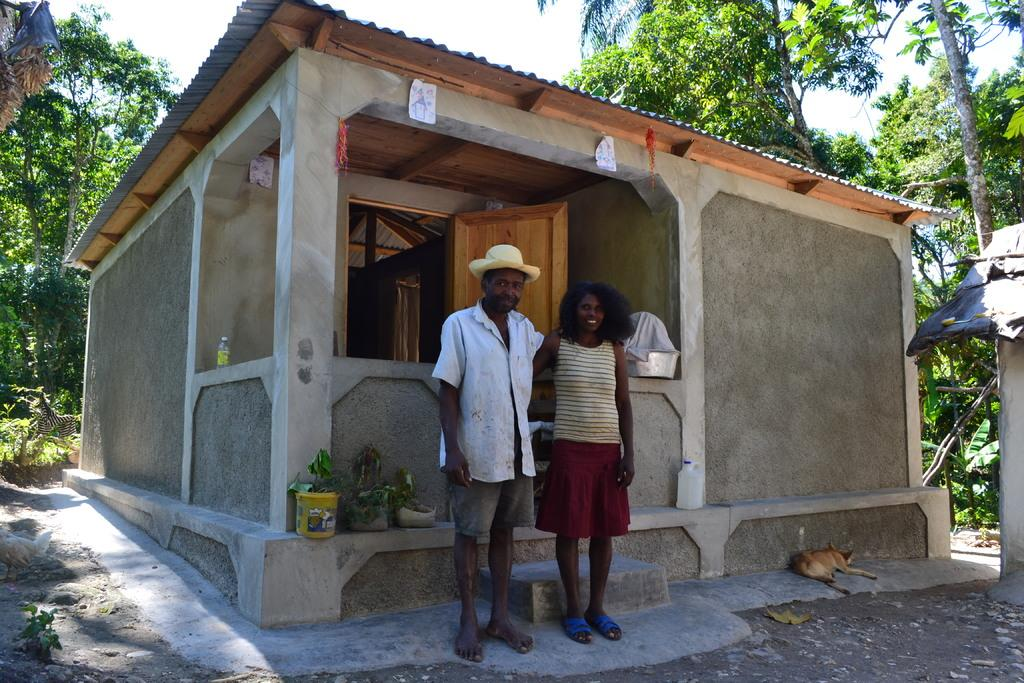How many people are present in the image? There are two people, a man and a woman, present in the image. What are the positions of the man and woman in the image? Both the man and woman are standing in the image. What can be seen in the background of the image? There is a building and trees in the background of the image. What type of line is being used by the scarecrow in the image? There is no scarecrow present in the image, so it is not possible to determine what type of line might be used. 